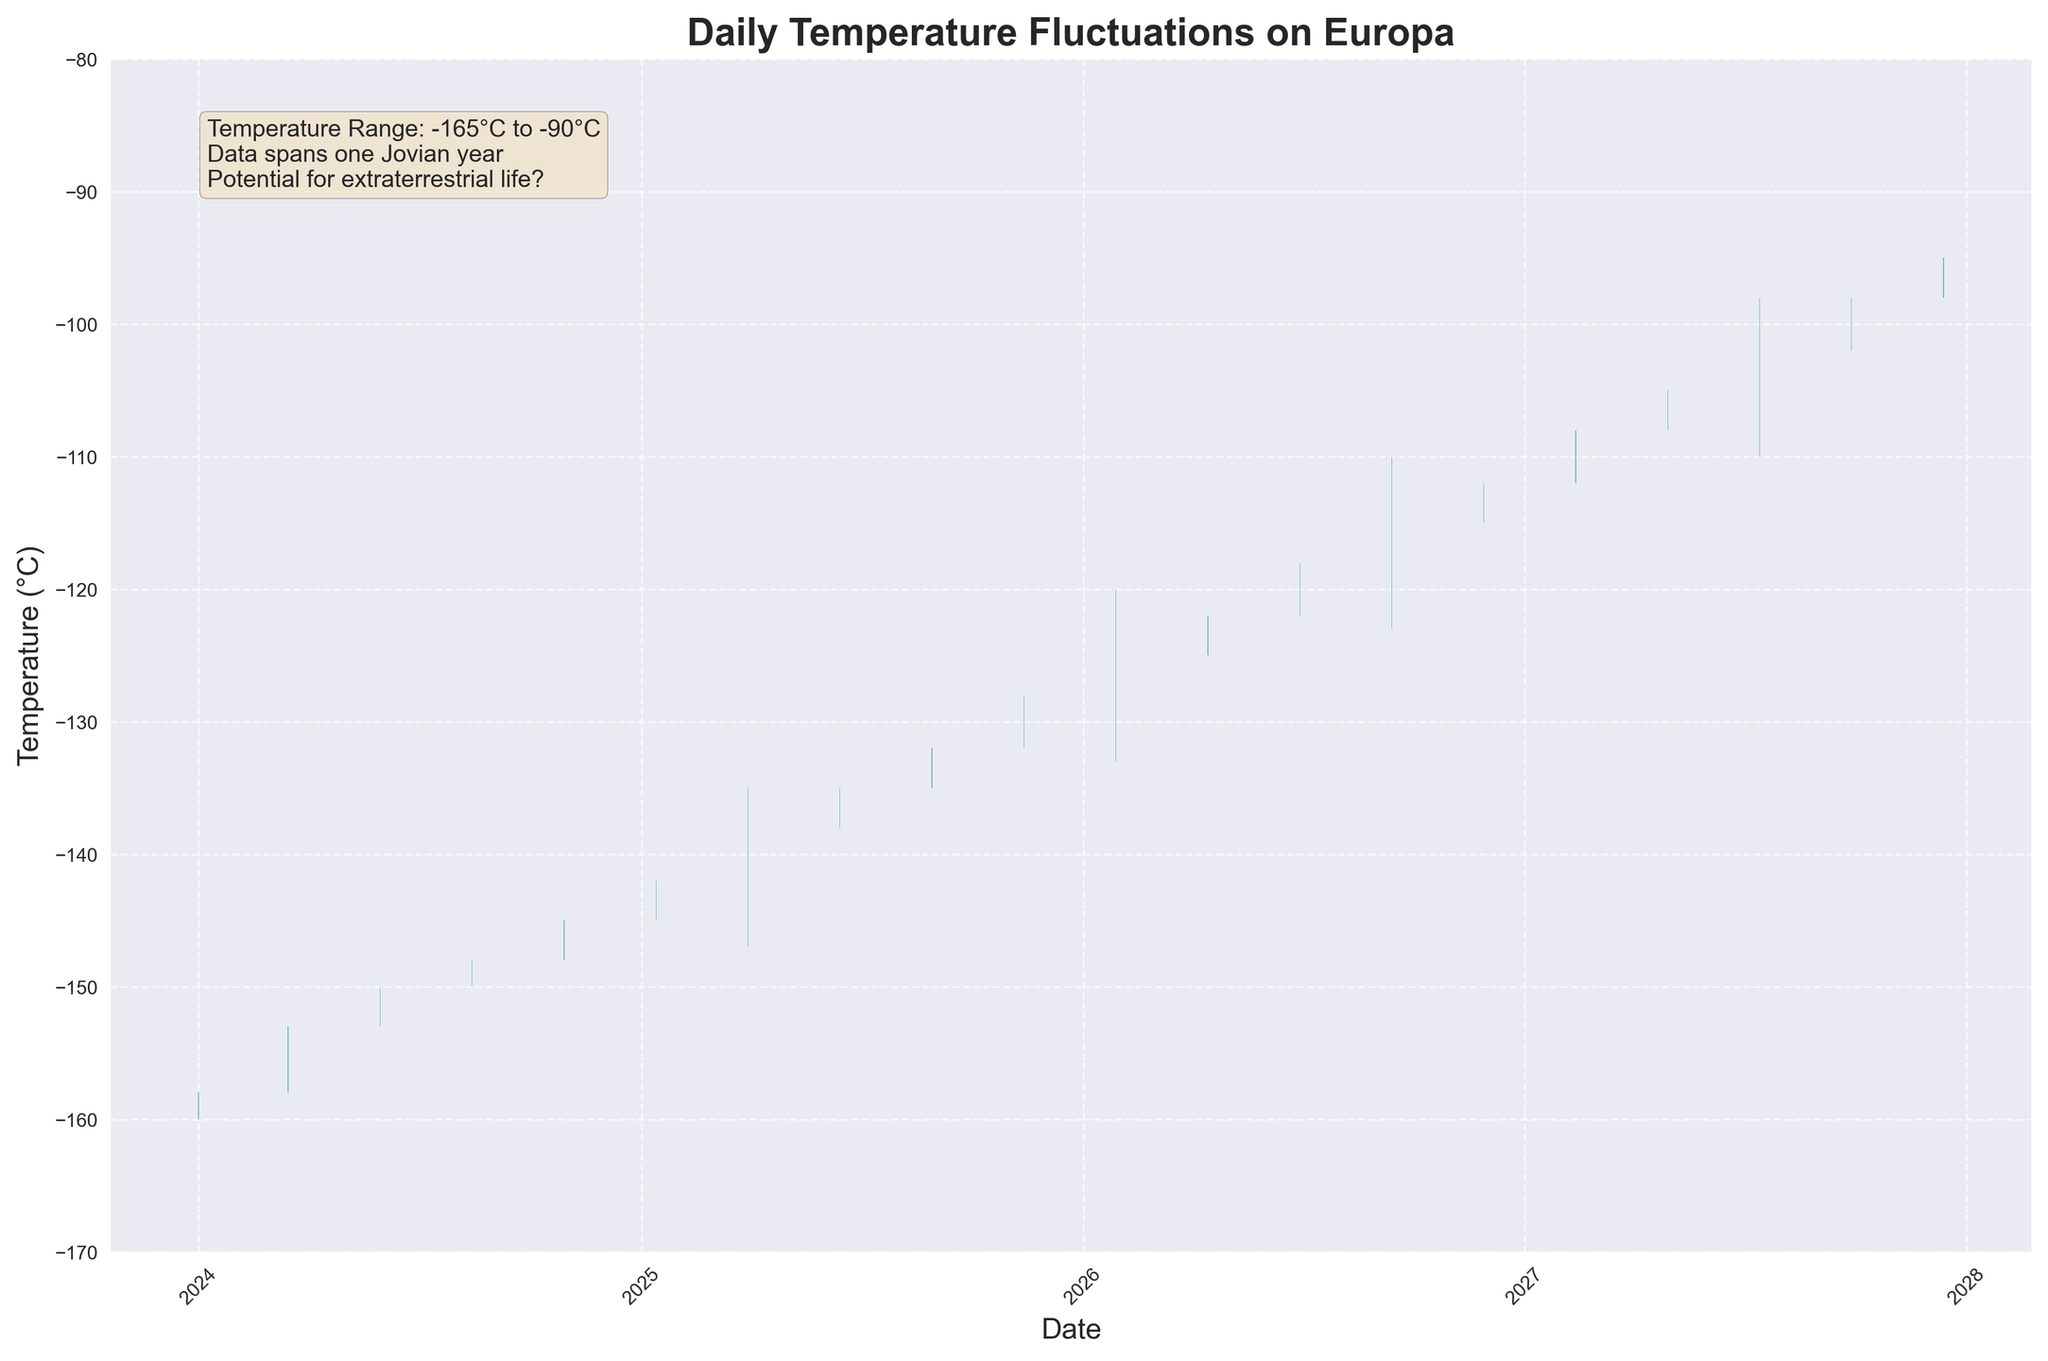What is the title of the figure? The title is prominently displayed at the top of the chart and describes the focus of the visualization.
Answer: Daily Temperature Fluctuations on Europa What temperature range is covered in the figure? The temperature range is listed in the text box and visible on the y-axis.
Answer: -165°C to -90°C How many data points are shown in the chart? By counting the number of bars displayed on the x-axis, we can determine the number of data points.
Answer: 20 What is the highest temperature recorded in the data? The highest temperature is the maximum value in the "High" column in the data table.
Answer: -90°C Which date had the largest daily temperature range? The largest daily temperature range is determined by the difference between the "High" and "Low" values for each date. Compare these differences to find the maximum.
Answer: 2027-12-13 How does the temperature trend change over the Jovian year? By observing the overall pattern of the OHLC bars, one can see whether the temperature generally increases, decreases, or remains the same over time.
Answer: Generally increases Which date had the lowest closing temperature? The lowest closing temperature is the minimum value in the "Close" column in the data table.
Answer: 2024-01-01 Is there a trend in the highest temperatures over the Jovian year? By looking at the "High" values on the bars as time progresses, one can identify if there's an increasing or decreasing trend.
Answer: Increasing trend On which date did the temperature close closest to the opening value? Check the dates where "Close" value is closest to the "Open" value by calculating the absolute differences and finding the smallest one.
Answer: 2025-11-13 Which segment of the year shows the most variable temperatures? Visually analyze the lengths of the OHLC bars, focusing on sections of the x-axis representing segments of the year to identify the most varying fluctuations.
Answer: Early to mid-2027 